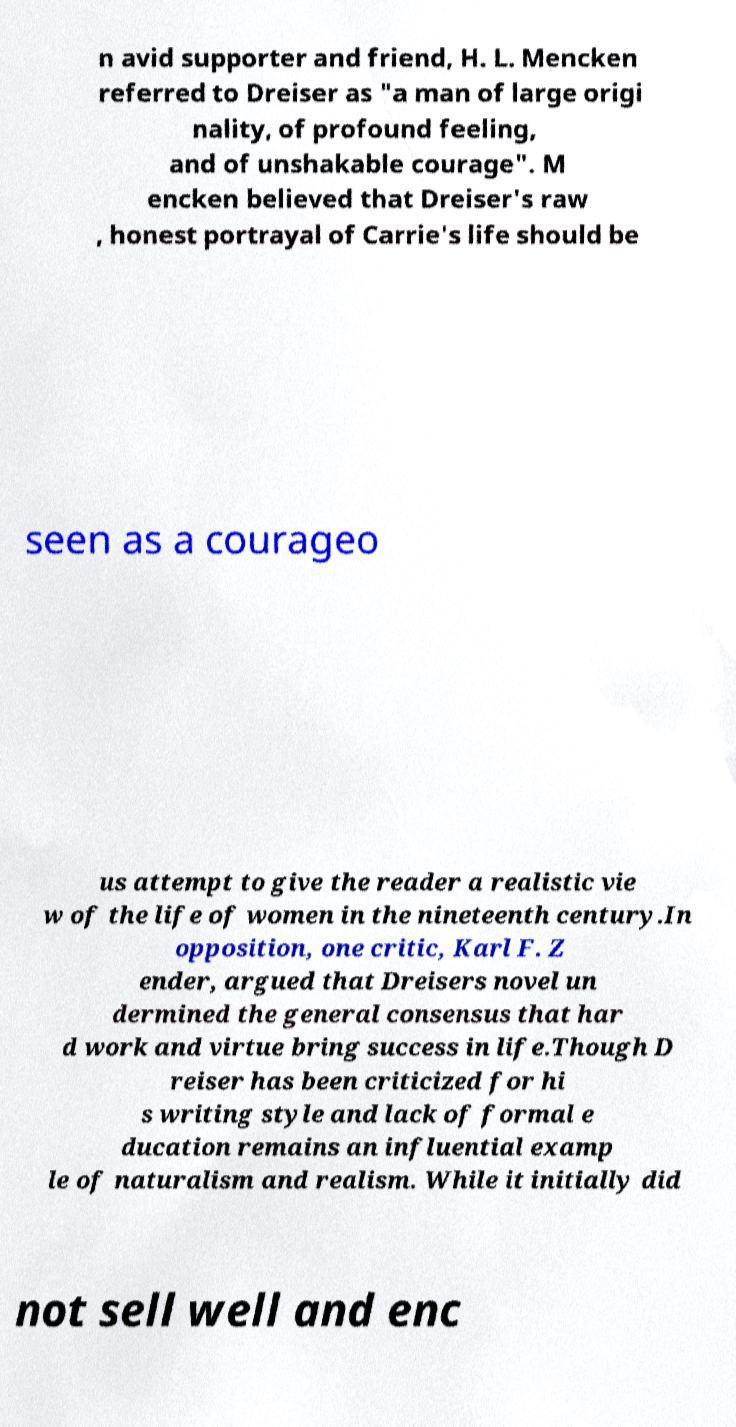What messages or text are displayed in this image? I need them in a readable, typed format. n avid supporter and friend, H. L. Mencken referred to Dreiser as "a man of large origi nality, of profound feeling, and of unshakable courage". M encken believed that Dreiser's raw , honest portrayal of Carrie's life should be seen as a courageo us attempt to give the reader a realistic vie w of the life of women in the nineteenth century.In opposition, one critic, Karl F. Z ender, argued that Dreisers novel un dermined the general consensus that har d work and virtue bring success in life.Though D reiser has been criticized for hi s writing style and lack of formal e ducation remains an influential examp le of naturalism and realism. While it initially did not sell well and enc 